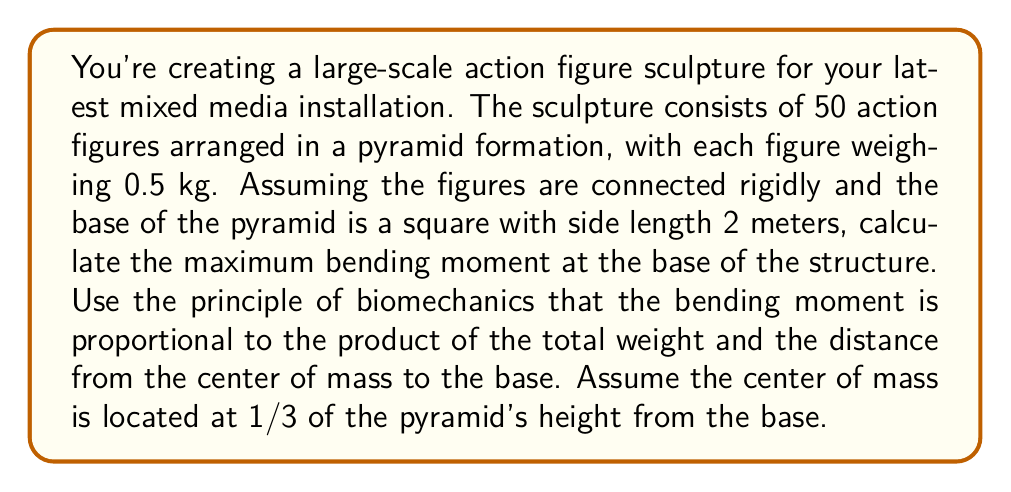Can you solve this math problem? To solve this problem, we'll follow these steps:

1. Calculate the total weight of the structure:
   Total weight = Number of figures × Weight per figure
   $W = 50 \times 0.5 \text{ kg} = 25 \text{ kg}$

2. Calculate the height of the pyramid:
   For a square pyramid, height $h$ is related to the base side length $a$ by:
   $h = \sqrt{\frac{a^2}{2}}$
   $h = \sqrt{\frac{2^2}{2}} = \sqrt{2} \approx 1.414 \text{ m}$

3. Determine the location of the center of mass:
   The center of mass is at 1/3 of the height from the base:
   $h_{CM} = \frac{1}{3} \times 1.414 \text{ m} \approx 0.471 \text{ m}$

4. Calculate the bending moment:
   The bending moment $M$ is given by:
   $M = W \times d$
   Where $W$ is the total weight and $d$ is the distance from the center of mass to the edge of the base.

   The distance $d$ is half the diagonal of the base square:
   $d = \frac{\sqrt{2}}{2} \times 2 \text{ m} = \sqrt{2} \text{ m} \approx 1.414 \text{ m}$

   Therefore, the bending moment is:
   $M = 25 \text{ kg} \times 9.81 \text{ m/s}^2 \times 1.414 \text{ m}$

5. Convert the result to N·m:
   $M = 346.93 \text{ N·m}$

This bending moment represents the maximum stress on the base of the structure, which is crucial for ensuring its structural stability.
Answer: The maximum bending moment at the base of the action figure sculpture is approximately 346.93 N·m. 